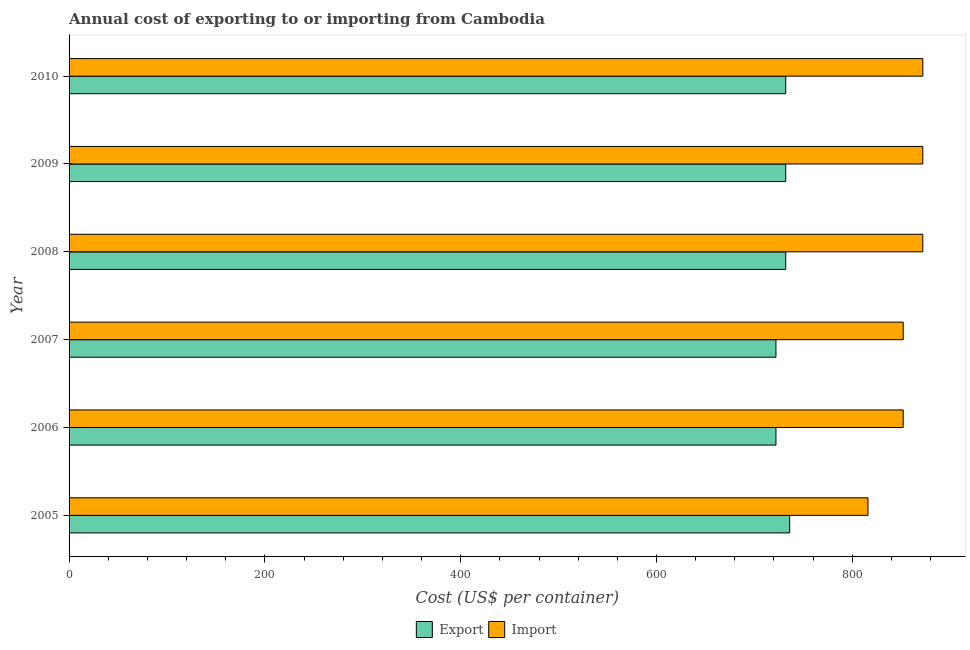Are the number of bars per tick equal to the number of legend labels?
Offer a very short reply. Yes. What is the label of the 1st group of bars from the top?
Your answer should be very brief. 2010. What is the export cost in 2010?
Provide a short and direct response. 732. Across all years, what is the maximum export cost?
Your response must be concise. 736. Across all years, what is the minimum export cost?
Your answer should be very brief. 722. In which year was the export cost maximum?
Provide a succinct answer. 2005. In which year was the import cost minimum?
Give a very brief answer. 2005. What is the total import cost in the graph?
Offer a terse response. 5136. What is the difference between the import cost in 2006 and that in 2008?
Your answer should be very brief. -20. What is the difference between the import cost in 2006 and the export cost in 2007?
Give a very brief answer. 130. What is the average export cost per year?
Keep it short and to the point. 729.33. In the year 2005, what is the difference between the import cost and export cost?
Your response must be concise. 80. In how many years, is the export cost greater than 480 US$?
Your response must be concise. 6. What is the ratio of the import cost in 2005 to that in 2007?
Give a very brief answer. 0.96. Is the export cost in 2005 less than that in 2009?
Provide a succinct answer. No. Is the difference between the export cost in 2007 and 2009 greater than the difference between the import cost in 2007 and 2009?
Give a very brief answer. Yes. What is the difference between the highest and the lowest export cost?
Provide a short and direct response. 14. Is the sum of the export cost in 2005 and 2010 greater than the maximum import cost across all years?
Make the answer very short. Yes. What does the 2nd bar from the top in 2008 represents?
Provide a succinct answer. Export. What does the 1st bar from the bottom in 2008 represents?
Ensure brevity in your answer.  Export. How many bars are there?
Provide a succinct answer. 12. Are all the bars in the graph horizontal?
Your response must be concise. Yes. How many years are there in the graph?
Your answer should be very brief. 6. What is the difference between two consecutive major ticks on the X-axis?
Make the answer very short. 200. What is the title of the graph?
Provide a short and direct response. Annual cost of exporting to or importing from Cambodia. Does "Lowest 20% of population" appear as one of the legend labels in the graph?
Your answer should be very brief. No. What is the label or title of the X-axis?
Ensure brevity in your answer.  Cost (US$ per container). What is the label or title of the Y-axis?
Give a very brief answer. Year. What is the Cost (US$ per container) of Export in 2005?
Offer a very short reply. 736. What is the Cost (US$ per container) of Import in 2005?
Offer a very short reply. 816. What is the Cost (US$ per container) of Export in 2006?
Provide a succinct answer. 722. What is the Cost (US$ per container) of Import in 2006?
Your answer should be very brief. 852. What is the Cost (US$ per container) of Export in 2007?
Give a very brief answer. 722. What is the Cost (US$ per container) in Import in 2007?
Give a very brief answer. 852. What is the Cost (US$ per container) in Export in 2008?
Offer a terse response. 732. What is the Cost (US$ per container) in Import in 2008?
Ensure brevity in your answer.  872. What is the Cost (US$ per container) in Export in 2009?
Offer a very short reply. 732. What is the Cost (US$ per container) in Import in 2009?
Ensure brevity in your answer.  872. What is the Cost (US$ per container) of Export in 2010?
Keep it short and to the point. 732. What is the Cost (US$ per container) of Import in 2010?
Your answer should be very brief. 872. Across all years, what is the maximum Cost (US$ per container) of Export?
Make the answer very short. 736. Across all years, what is the maximum Cost (US$ per container) of Import?
Make the answer very short. 872. Across all years, what is the minimum Cost (US$ per container) in Export?
Provide a short and direct response. 722. Across all years, what is the minimum Cost (US$ per container) in Import?
Your answer should be very brief. 816. What is the total Cost (US$ per container) of Export in the graph?
Your answer should be compact. 4376. What is the total Cost (US$ per container) in Import in the graph?
Your answer should be very brief. 5136. What is the difference between the Cost (US$ per container) of Export in 2005 and that in 2006?
Your answer should be very brief. 14. What is the difference between the Cost (US$ per container) in Import in 2005 and that in 2006?
Provide a short and direct response. -36. What is the difference between the Cost (US$ per container) in Import in 2005 and that in 2007?
Provide a succinct answer. -36. What is the difference between the Cost (US$ per container) in Import in 2005 and that in 2008?
Your response must be concise. -56. What is the difference between the Cost (US$ per container) of Import in 2005 and that in 2009?
Your response must be concise. -56. What is the difference between the Cost (US$ per container) in Import in 2005 and that in 2010?
Give a very brief answer. -56. What is the difference between the Cost (US$ per container) of Export in 2006 and that in 2008?
Make the answer very short. -10. What is the difference between the Cost (US$ per container) in Import in 2006 and that in 2008?
Offer a very short reply. -20. What is the difference between the Cost (US$ per container) in Import in 2006 and that in 2009?
Keep it short and to the point. -20. What is the difference between the Cost (US$ per container) of Export in 2007 and that in 2008?
Offer a terse response. -10. What is the difference between the Cost (US$ per container) of Import in 2007 and that in 2008?
Provide a short and direct response. -20. What is the difference between the Cost (US$ per container) of Export in 2007 and that in 2009?
Provide a short and direct response. -10. What is the difference between the Cost (US$ per container) of Import in 2007 and that in 2009?
Provide a succinct answer. -20. What is the difference between the Cost (US$ per container) of Export in 2007 and that in 2010?
Ensure brevity in your answer.  -10. What is the difference between the Cost (US$ per container) of Export in 2008 and that in 2009?
Provide a succinct answer. 0. What is the difference between the Cost (US$ per container) in Import in 2008 and that in 2009?
Give a very brief answer. 0. What is the difference between the Cost (US$ per container) of Import in 2008 and that in 2010?
Make the answer very short. 0. What is the difference between the Cost (US$ per container) in Export in 2009 and that in 2010?
Your answer should be very brief. 0. What is the difference between the Cost (US$ per container) in Import in 2009 and that in 2010?
Provide a succinct answer. 0. What is the difference between the Cost (US$ per container) in Export in 2005 and the Cost (US$ per container) in Import in 2006?
Your answer should be compact. -116. What is the difference between the Cost (US$ per container) of Export in 2005 and the Cost (US$ per container) of Import in 2007?
Make the answer very short. -116. What is the difference between the Cost (US$ per container) in Export in 2005 and the Cost (US$ per container) in Import in 2008?
Give a very brief answer. -136. What is the difference between the Cost (US$ per container) in Export in 2005 and the Cost (US$ per container) in Import in 2009?
Give a very brief answer. -136. What is the difference between the Cost (US$ per container) of Export in 2005 and the Cost (US$ per container) of Import in 2010?
Keep it short and to the point. -136. What is the difference between the Cost (US$ per container) of Export in 2006 and the Cost (US$ per container) of Import in 2007?
Provide a short and direct response. -130. What is the difference between the Cost (US$ per container) of Export in 2006 and the Cost (US$ per container) of Import in 2008?
Your response must be concise. -150. What is the difference between the Cost (US$ per container) in Export in 2006 and the Cost (US$ per container) in Import in 2009?
Keep it short and to the point. -150. What is the difference between the Cost (US$ per container) of Export in 2006 and the Cost (US$ per container) of Import in 2010?
Give a very brief answer. -150. What is the difference between the Cost (US$ per container) in Export in 2007 and the Cost (US$ per container) in Import in 2008?
Your response must be concise. -150. What is the difference between the Cost (US$ per container) of Export in 2007 and the Cost (US$ per container) of Import in 2009?
Provide a short and direct response. -150. What is the difference between the Cost (US$ per container) in Export in 2007 and the Cost (US$ per container) in Import in 2010?
Keep it short and to the point. -150. What is the difference between the Cost (US$ per container) in Export in 2008 and the Cost (US$ per container) in Import in 2009?
Your response must be concise. -140. What is the difference between the Cost (US$ per container) of Export in 2008 and the Cost (US$ per container) of Import in 2010?
Give a very brief answer. -140. What is the difference between the Cost (US$ per container) of Export in 2009 and the Cost (US$ per container) of Import in 2010?
Provide a succinct answer. -140. What is the average Cost (US$ per container) in Export per year?
Provide a short and direct response. 729.33. What is the average Cost (US$ per container) of Import per year?
Your response must be concise. 856. In the year 2005, what is the difference between the Cost (US$ per container) of Export and Cost (US$ per container) of Import?
Provide a succinct answer. -80. In the year 2006, what is the difference between the Cost (US$ per container) of Export and Cost (US$ per container) of Import?
Offer a terse response. -130. In the year 2007, what is the difference between the Cost (US$ per container) of Export and Cost (US$ per container) of Import?
Provide a succinct answer. -130. In the year 2008, what is the difference between the Cost (US$ per container) of Export and Cost (US$ per container) of Import?
Make the answer very short. -140. In the year 2009, what is the difference between the Cost (US$ per container) in Export and Cost (US$ per container) in Import?
Your answer should be compact. -140. In the year 2010, what is the difference between the Cost (US$ per container) of Export and Cost (US$ per container) of Import?
Provide a succinct answer. -140. What is the ratio of the Cost (US$ per container) in Export in 2005 to that in 2006?
Keep it short and to the point. 1.02. What is the ratio of the Cost (US$ per container) of Import in 2005 to that in 2006?
Your response must be concise. 0.96. What is the ratio of the Cost (US$ per container) of Export in 2005 to that in 2007?
Provide a succinct answer. 1.02. What is the ratio of the Cost (US$ per container) in Import in 2005 to that in 2007?
Provide a short and direct response. 0.96. What is the ratio of the Cost (US$ per container) in Import in 2005 to that in 2008?
Provide a short and direct response. 0.94. What is the ratio of the Cost (US$ per container) of Import in 2005 to that in 2009?
Your answer should be very brief. 0.94. What is the ratio of the Cost (US$ per container) in Import in 2005 to that in 2010?
Your answer should be very brief. 0.94. What is the ratio of the Cost (US$ per container) of Export in 2006 to that in 2007?
Offer a very short reply. 1. What is the ratio of the Cost (US$ per container) of Export in 2006 to that in 2008?
Give a very brief answer. 0.99. What is the ratio of the Cost (US$ per container) in Import in 2006 to that in 2008?
Give a very brief answer. 0.98. What is the ratio of the Cost (US$ per container) of Export in 2006 to that in 2009?
Ensure brevity in your answer.  0.99. What is the ratio of the Cost (US$ per container) of Import in 2006 to that in 2009?
Make the answer very short. 0.98. What is the ratio of the Cost (US$ per container) in Export in 2006 to that in 2010?
Provide a succinct answer. 0.99. What is the ratio of the Cost (US$ per container) of Import in 2006 to that in 2010?
Your answer should be compact. 0.98. What is the ratio of the Cost (US$ per container) of Export in 2007 to that in 2008?
Your response must be concise. 0.99. What is the ratio of the Cost (US$ per container) in Import in 2007 to that in 2008?
Offer a very short reply. 0.98. What is the ratio of the Cost (US$ per container) in Export in 2007 to that in 2009?
Offer a very short reply. 0.99. What is the ratio of the Cost (US$ per container) in Import in 2007 to that in 2009?
Provide a short and direct response. 0.98. What is the ratio of the Cost (US$ per container) of Export in 2007 to that in 2010?
Provide a short and direct response. 0.99. What is the ratio of the Cost (US$ per container) of Import in 2007 to that in 2010?
Your answer should be compact. 0.98. What is the ratio of the Cost (US$ per container) of Import in 2008 to that in 2009?
Keep it short and to the point. 1. What is the ratio of the Cost (US$ per container) in Export in 2008 to that in 2010?
Your response must be concise. 1. What is the ratio of the Cost (US$ per container) of Import in 2008 to that in 2010?
Your answer should be compact. 1. What is the ratio of the Cost (US$ per container) of Export in 2009 to that in 2010?
Offer a very short reply. 1. What is the ratio of the Cost (US$ per container) of Import in 2009 to that in 2010?
Make the answer very short. 1. What is the difference between the highest and the second highest Cost (US$ per container) of Export?
Give a very brief answer. 4. 